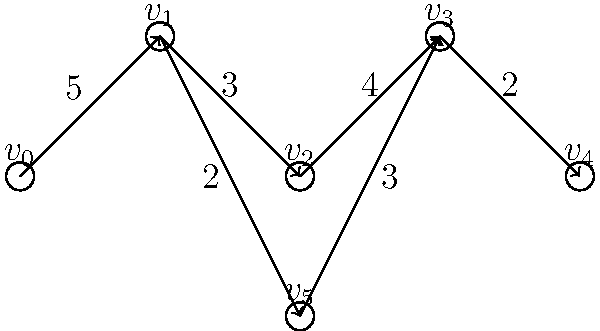Given the directed graph representing a production line, where vertices represent workstations and edge weights represent processing times (in minutes), what is the bottleneck of the system, and what is the minimum time required to process one unit through the entire line? To find the bottleneck and minimum processing time, we need to:

1. Identify all possible paths from start ($v_0$) to end ($v_4$).
2. Calculate the total processing time for each path.
3. Determine the critical path (longest total processing time).

Possible paths:
1. $v_0 \rightarrow v_1 \rightarrow v_2 \rightarrow v_3 \rightarrow v_4$
2. $v_0 \rightarrow v_1 \rightarrow v_5 \rightarrow v_3 \rightarrow v_4$

Calculating processing times:
1. Path 1: $5 + 3 + 4 + 2 = 14$ minutes
2. Path 2: $5 + 2 + 3 + 2 = 12$ minutes

The critical path is Path 1, with a total processing time of 14 minutes. This determines the minimum time required to process one unit through the entire line.

The bottleneck is the process or workstation that limits the overall system performance. In this case, it's the edge with the highest processing time on the critical path, which is the edge between $v_0$ and $v_1$ with a processing time of 5 minutes.
Answer: Bottleneck: $v_0 \rightarrow v_1$ (5 minutes); Minimum processing time: 14 minutes 